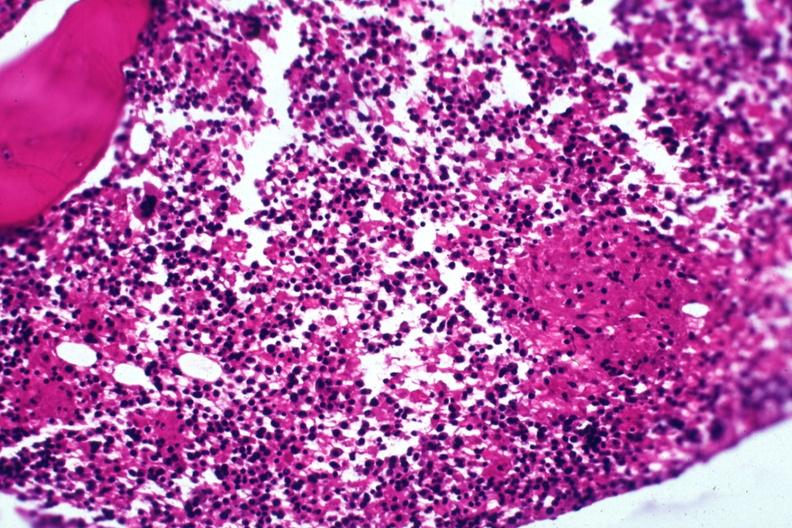what is present?
Answer the question using a single word or phrase. Bone marrow 